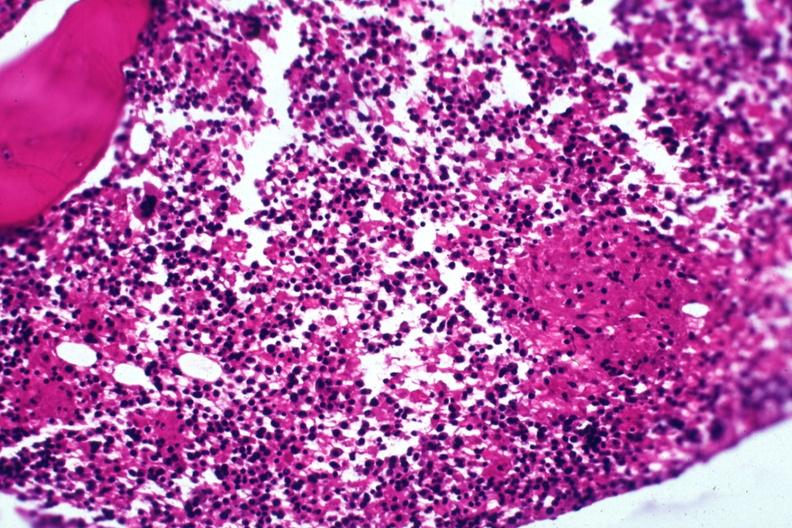what is present?
Answer the question using a single word or phrase. Bone marrow 